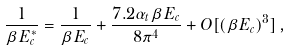<formula> <loc_0><loc_0><loc_500><loc_500>\frac { 1 } { \beta E _ { c } ^ { * } } = \frac { 1 } { \beta E _ { c } } + \frac { 7 . 2 \alpha _ { t } \beta E _ { c } } { 8 \pi ^ { 4 } } + O [ ( \beta E _ { c } ) ^ { 3 } ] \, ,</formula> 